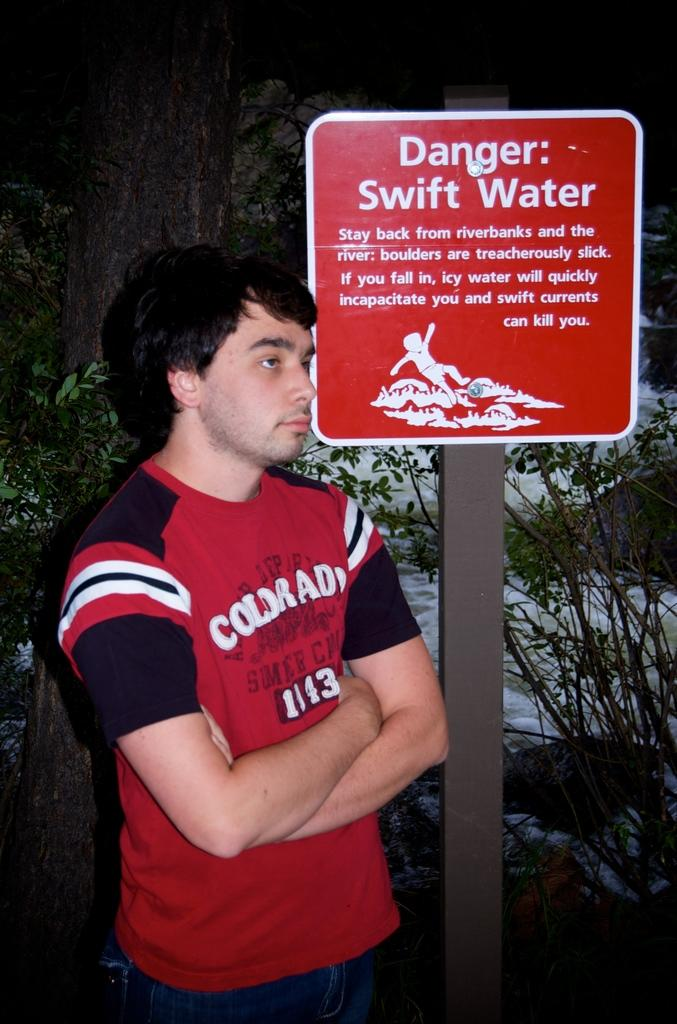<image>
Relay a brief, clear account of the picture shown. A man stands in front of a red sign that states Danger Swift Water. 